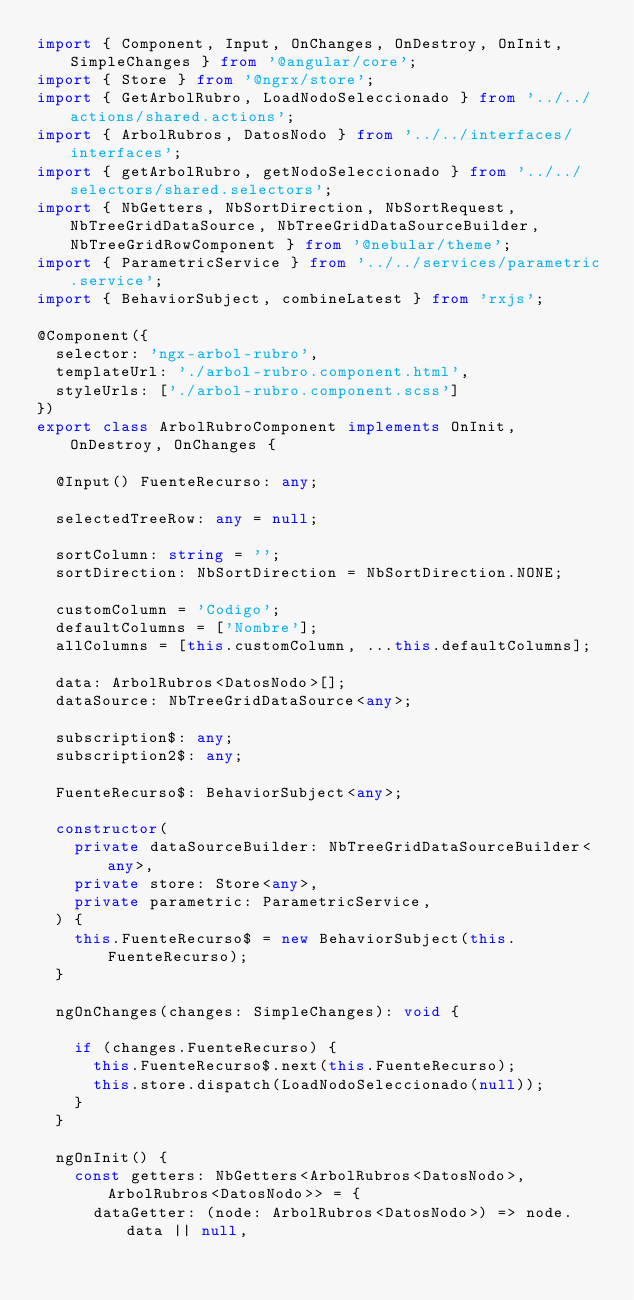<code> <loc_0><loc_0><loc_500><loc_500><_TypeScript_>import { Component, Input, OnChanges, OnDestroy, OnInit, SimpleChanges } from '@angular/core';
import { Store } from '@ngrx/store';
import { GetArbolRubro, LoadNodoSeleccionado } from '../../actions/shared.actions';
import { ArbolRubros, DatosNodo } from '../../interfaces/interfaces';
import { getArbolRubro, getNodoSeleccionado } from '../../selectors/shared.selectors';
import { NbGetters, NbSortDirection, NbSortRequest, NbTreeGridDataSource, NbTreeGridDataSourceBuilder, NbTreeGridRowComponent } from '@nebular/theme';
import { ParametricService } from '../../services/parametric.service';
import { BehaviorSubject, combineLatest } from 'rxjs';

@Component({
  selector: 'ngx-arbol-rubro',
  templateUrl: './arbol-rubro.component.html',
  styleUrls: ['./arbol-rubro.component.scss']
})
export class ArbolRubroComponent implements OnInit, OnDestroy, OnChanges {

  @Input() FuenteRecurso: any;

  selectedTreeRow: any = null;

  sortColumn: string = '';
  sortDirection: NbSortDirection = NbSortDirection.NONE;

  customColumn = 'Codigo';
  defaultColumns = ['Nombre'];
  allColumns = [this.customColumn, ...this.defaultColumns];

  data: ArbolRubros<DatosNodo>[];
  dataSource: NbTreeGridDataSource<any>;

  subscription$: any;
  subscription2$: any;

  FuenteRecurso$: BehaviorSubject<any>;

  constructor(
    private dataSourceBuilder: NbTreeGridDataSourceBuilder<any>,
    private store: Store<any>,
    private parametric: ParametricService,
  ) {
    this.FuenteRecurso$ = new BehaviorSubject(this.FuenteRecurso);
  }

  ngOnChanges(changes: SimpleChanges): void {

    if (changes.FuenteRecurso) {
      this.FuenteRecurso$.next(this.FuenteRecurso);
      this.store.dispatch(LoadNodoSeleccionado(null));
    }
  }

  ngOnInit() {
    const getters: NbGetters<ArbolRubros<DatosNodo>, ArbolRubros<DatosNodo>> = {
      dataGetter: (node: ArbolRubros<DatosNodo>) => node.data || null,</code> 